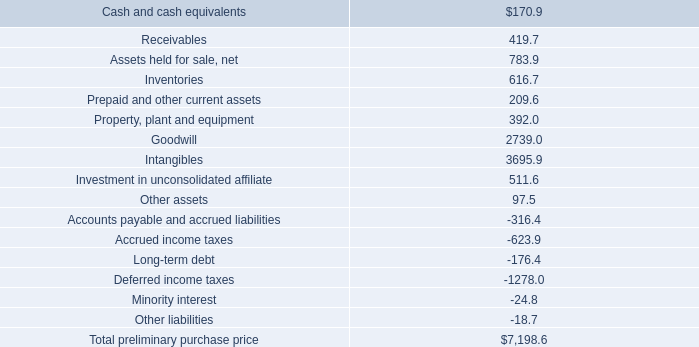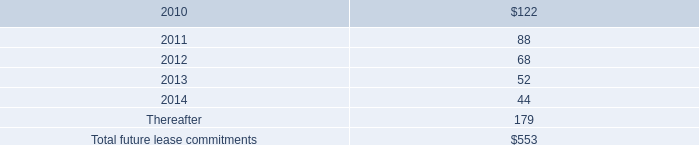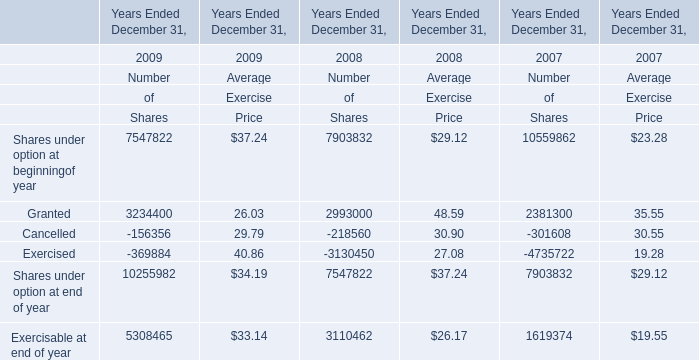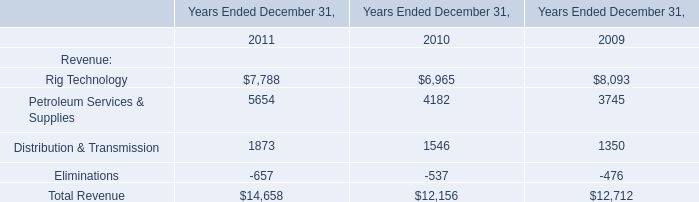What is the average amount of Rig Technology of Years Ended December 31, 2011, and Cancelled of Years Ended December 31, 2009 Number of Shares ? 
Computations: ((7788.0 + 156356.0) / 2)
Answer: 82072.0. 